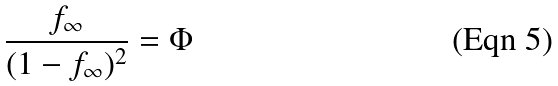Convert formula to latex. <formula><loc_0><loc_0><loc_500><loc_500>\frac { f _ { \infty } } { ( 1 - f _ { \infty } ) ^ { 2 } } = \Phi</formula> 